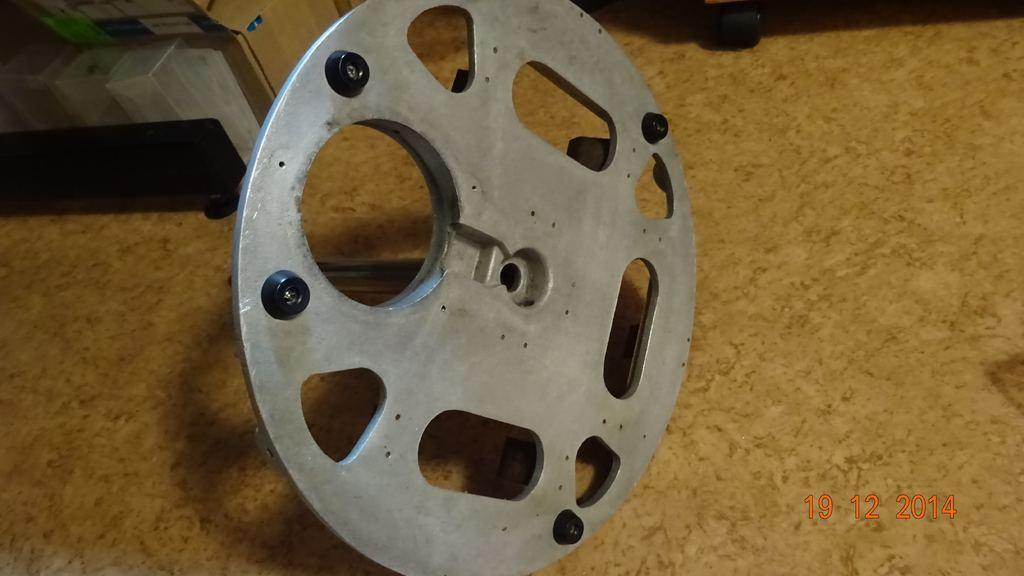In one or two sentences, can you explain what this image depicts? There is an aluminium wheel which is attached to the small rod on the floor. On the right side, there is watermark. In the background, there are other objects on the floor. 